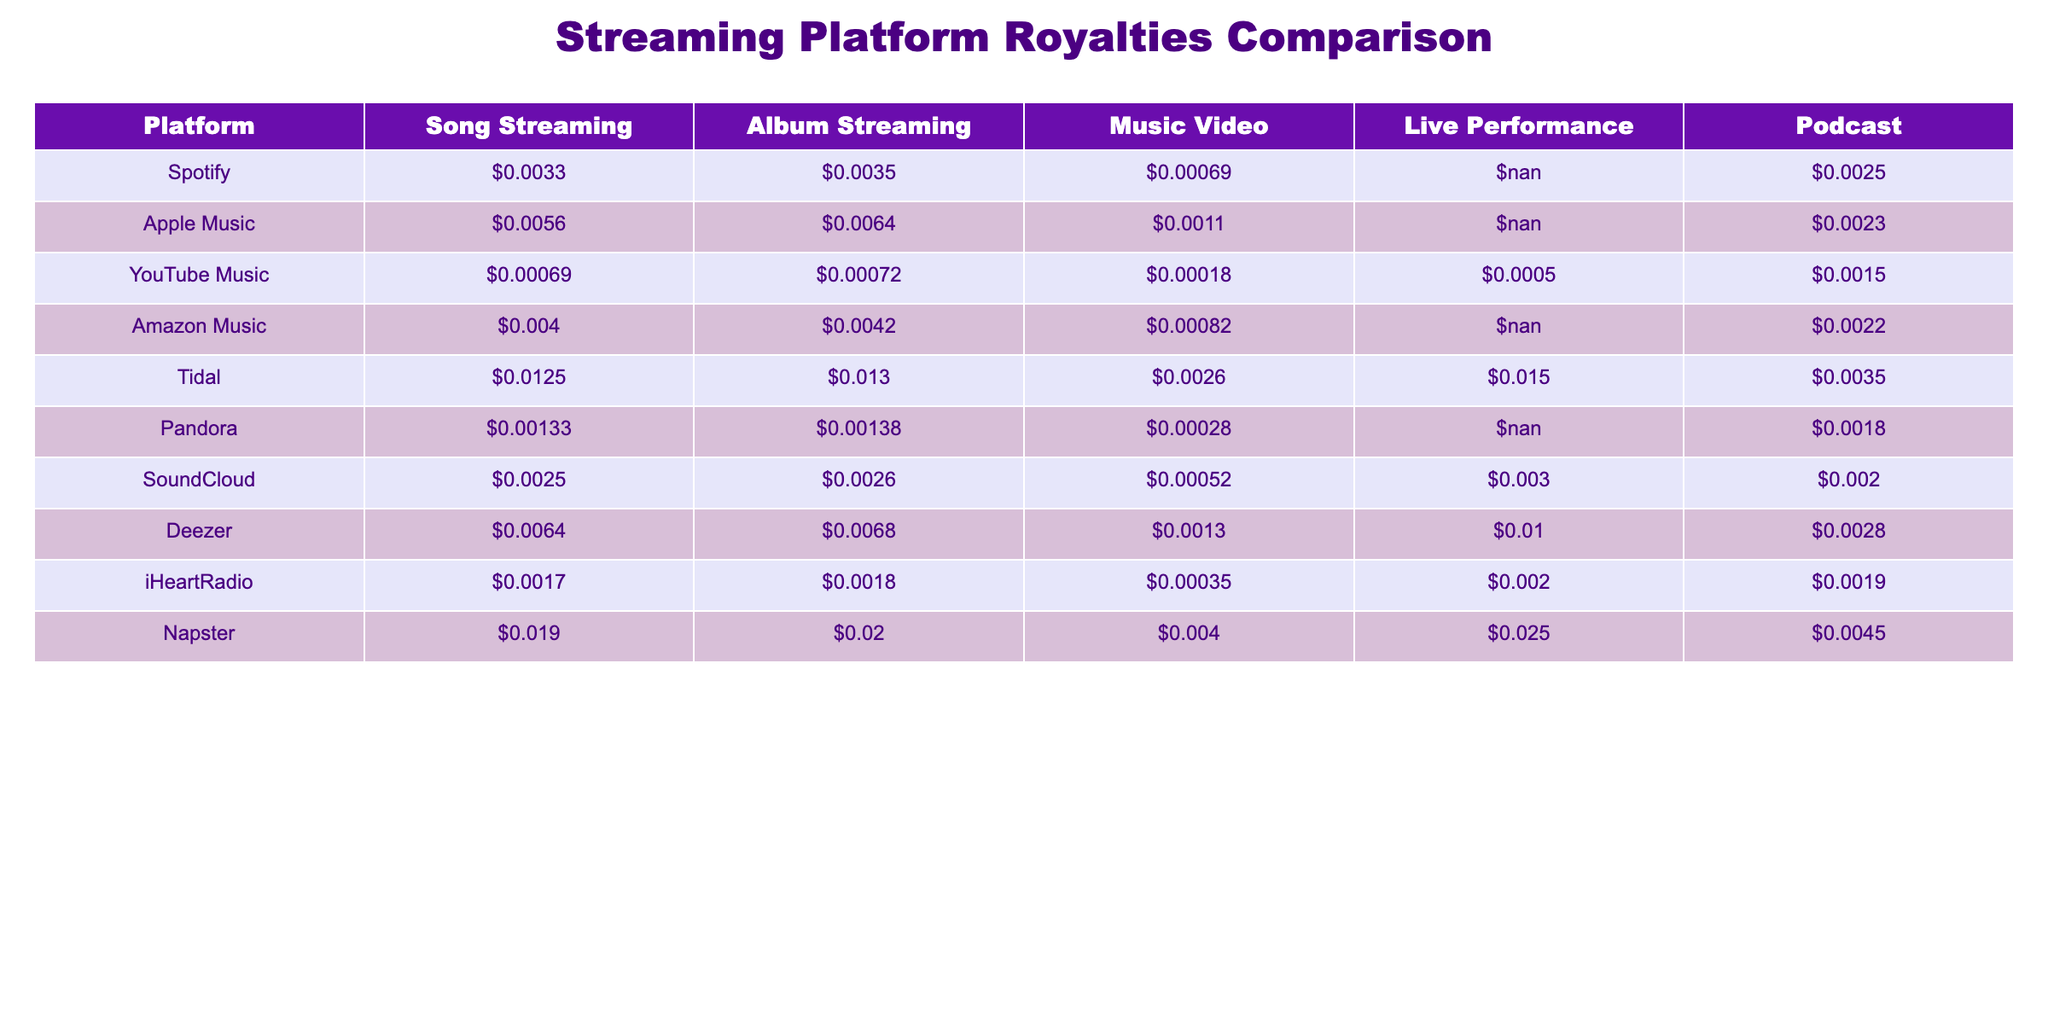What is the highest royalty for song streaming among these platforms? The highest royalty for song streaming can be found by comparing the values in the "Song Streaming" column. Review the values: $0.0033 (Spotify), $0.0056 (Apple Music), $0.00069 (YouTube Music), $0.004 (Amazon Music), $0.0125 (Tidal), $0.00133 (Pandora), $0.0025 (SoundCloud), $0.0064 (Deezer), $0.0017 (iHeartRadio), and $0.019 (Napster). The highest value is $0.019 (Napster).
Answer: $0.019 Which platform has the lowest royalty for album streaming? To find the platform with the lowest album streaming royalty, compare the values in the "Album Streaming" column. The values are: $0.0035 (Spotify), $0.0064 (Apple Music), $0.00072 (YouTube Music), $0.0042 (Amazon Music), $0.013 (Tidal), $0.00138 (Pandora), $0.0026 (SoundCloud), $0.0068 (Deezer), $0.0018 (iHeartRadio), and $0.02 (Napster). The lowest value is $0.00072 (YouTube Music).
Answer: YouTube Music Is the royalty for live performance higher on Tidal than on Napster? Compare the values for live performance royalties on both platforms: Tidal has $0.015 and Napster has $0.025. Since $0.015 is less than $0.025, Tidal's royalty is not higher than Napster's royalty.
Answer: No What is the combined royalty for podcast and song streaming on Apple Music? To find the combined royalty for podcast and song streaming on Apple Music, we take both values: $0.0056 (Song Streaming) and $0.0023 (Podcast). Add them together: $0.0056 + $0.0023 = $0.0079.
Answer: $0.0079 Does Pandora pay more per streaming for music videos compared to YouTube Music? For music video royalties, Pandora pays $0.00028, while YouTube Music pays $0.00018. Since $0.00028 is greater than $0.00018, Pandora does pay more for music videos.
Answer: Yes What is the average royalty for song streaming across all listed platforms? First, sum the royalties for song streaming: $0.0033 + $0.0056 + $0.00069 + $0.004 + $0.0125 + $0.00133 + $0.0025 + $0.0064 + $0.0017 + $0.019 = $0.05601. Then, divide by 10 (the number of platforms): $0.05601 / 10 = $0.005601.
Answer: $0.005601 